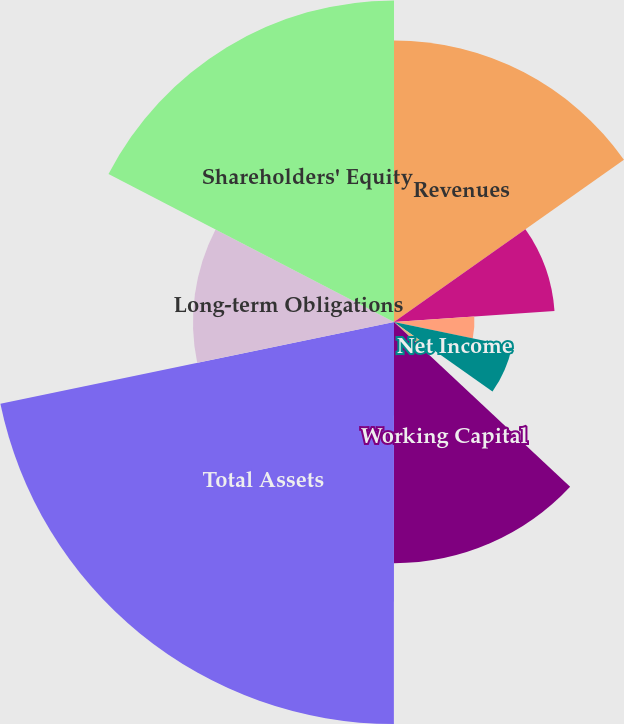Convert chart to OTSL. <chart><loc_0><loc_0><loc_500><loc_500><pie_chart><fcel>Revenues<fcel>Operating Income<fcel>Income from Continuing<fcel>Net Income<fcel>Basic<fcel>Diluted<fcel>Working Capital<fcel>Total Assets<fcel>Long-term Obligations<fcel>Shareholders' Equity<nl><fcel>15.22%<fcel>8.7%<fcel>4.35%<fcel>6.52%<fcel>2.18%<fcel>0.0%<fcel>13.04%<fcel>21.74%<fcel>10.87%<fcel>17.39%<nl></chart> 